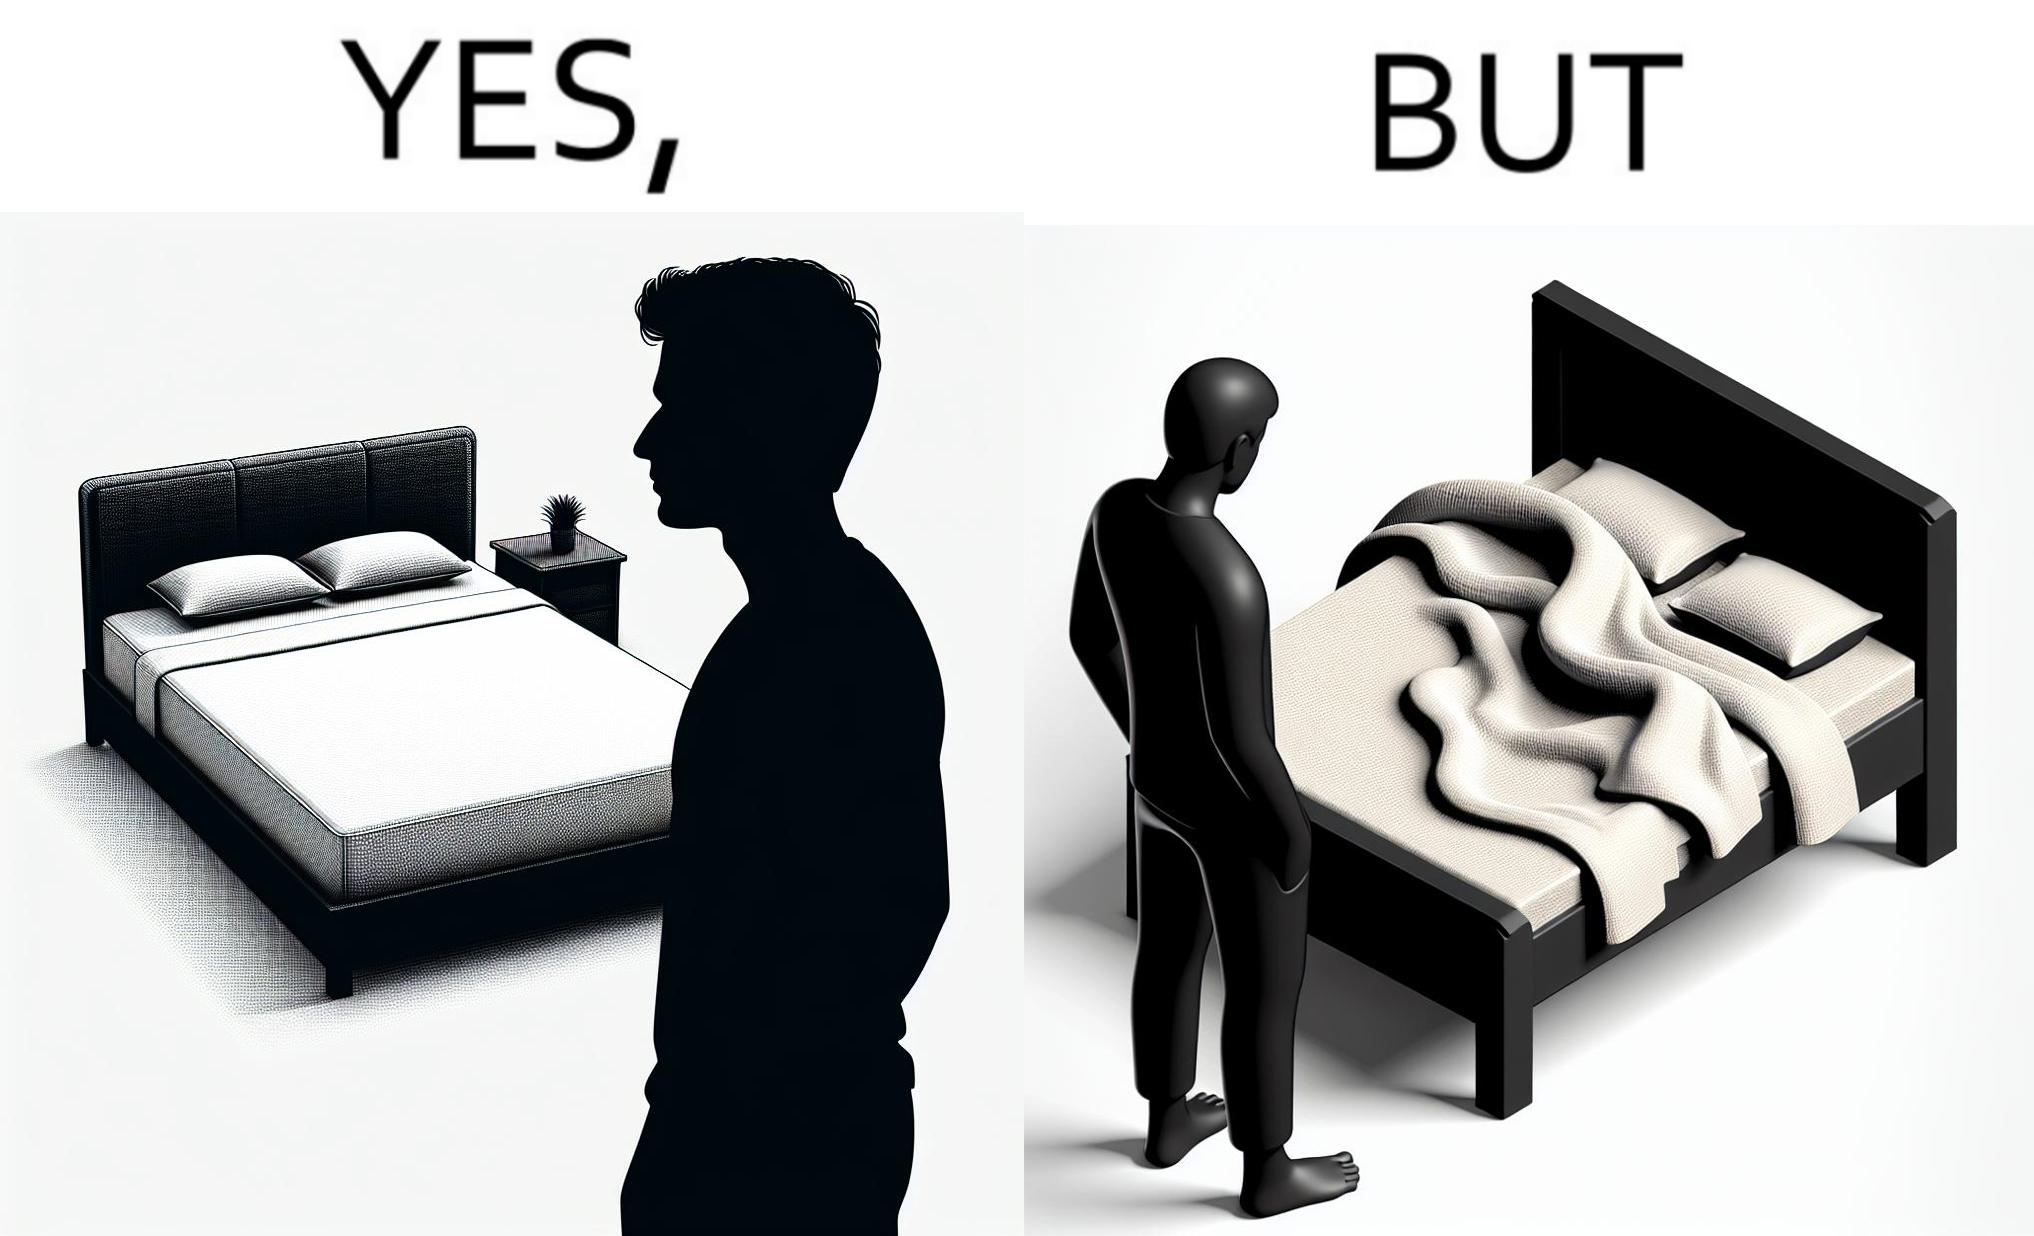What makes this image funny or satirical? The image is funny because while the bed seems to be well made with the blanket on top, the actual blanket inside the blanket cover is twisted and not properly set. 